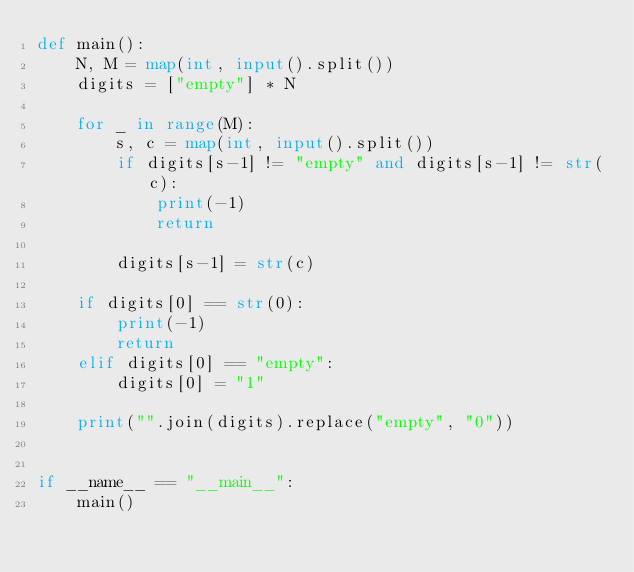<code> <loc_0><loc_0><loc_500><loc_500><_Python_>def main():
    N, M = map(int, input().split())
    digits = ["empty"] * N

    for _ in range(M):
        s, c = map(int, input().split())
        if digits[s-1] != "empty" and digits[s-1] != str(c):
            print(-1)
            return

        digits[s-1] = str(c)

    if digits[0] == str(0):
        print(-1)
        return
    elif digits[0] == "empty":
        digits[0] = "1"

    print("".join(digits).replace("empty", "0"))


if __name__ == "__main__":
    main()
</code> 